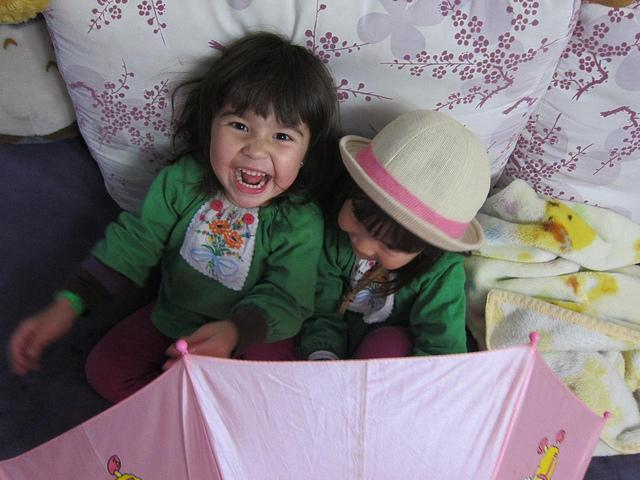What does it look like these girls are? twins 